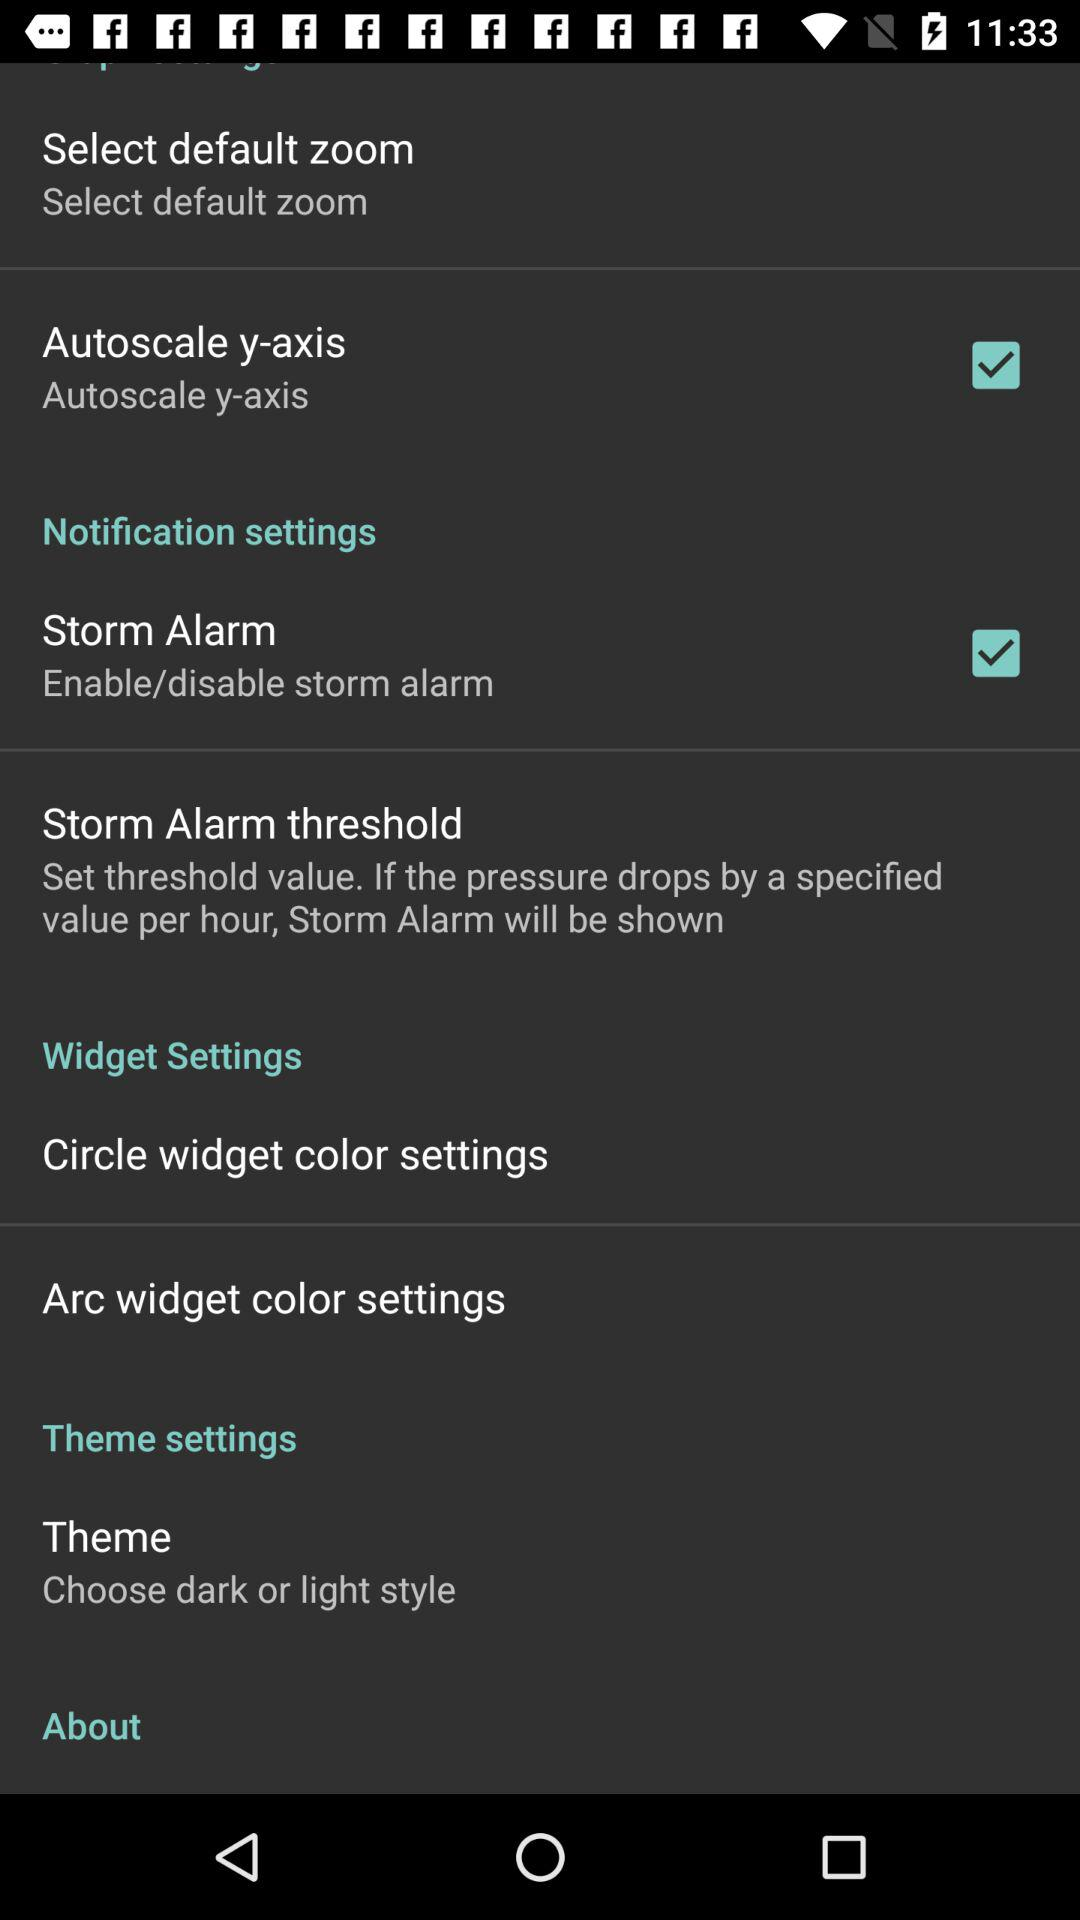What is the status of the storm alarm? The status is on. 